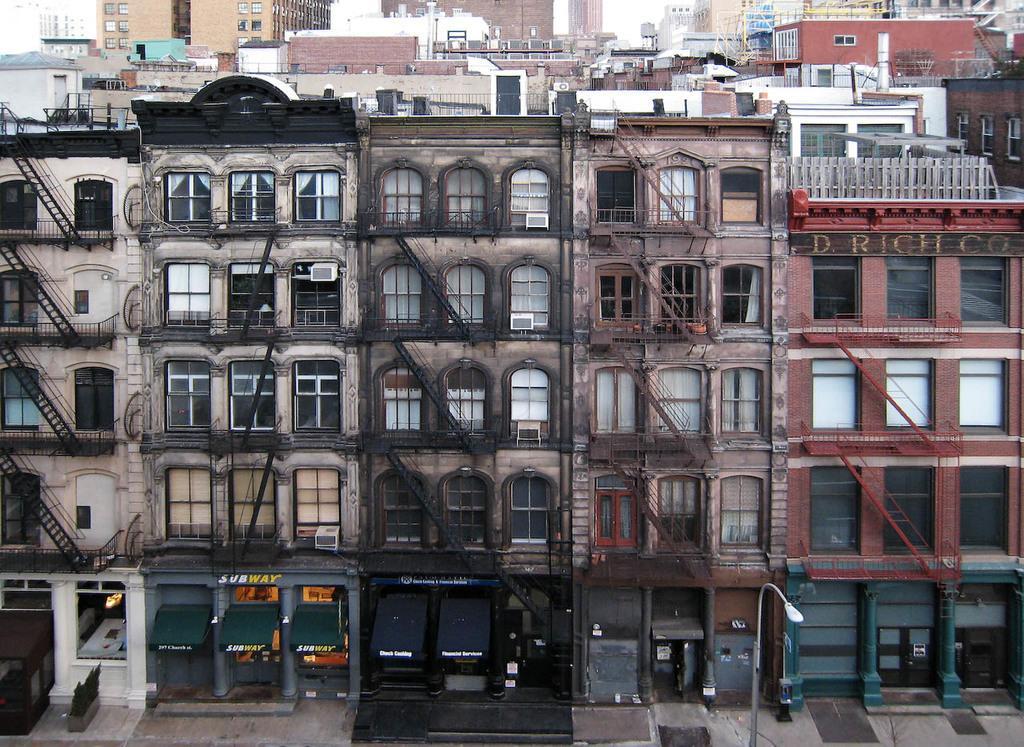Describe this image in one or two sentences. In this image there are buildings, railings, windows, stores, light pole, plants and objects. 